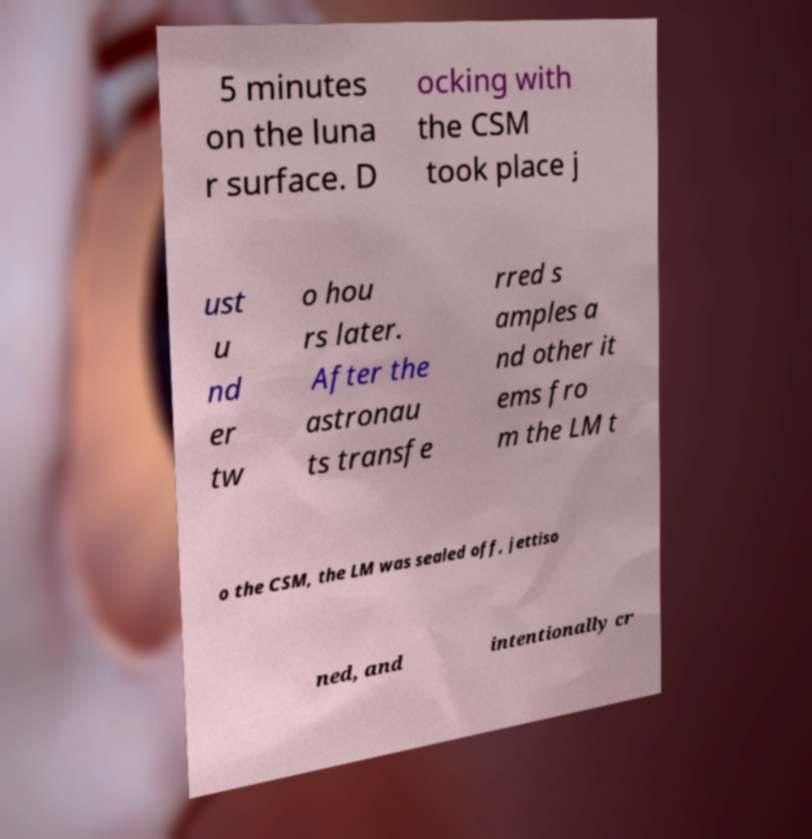Please read and relay the text visible in this image. What does it say? 5 minutes on the luna r surface. D ocking with the CSM took place j ust u nd er tw o hou rs later. After the astronau ts transfe rred s amples a nd other it ems fro m the LM t o the CSM, the LM was sealed off, jettiso ned, and intentionally cr 